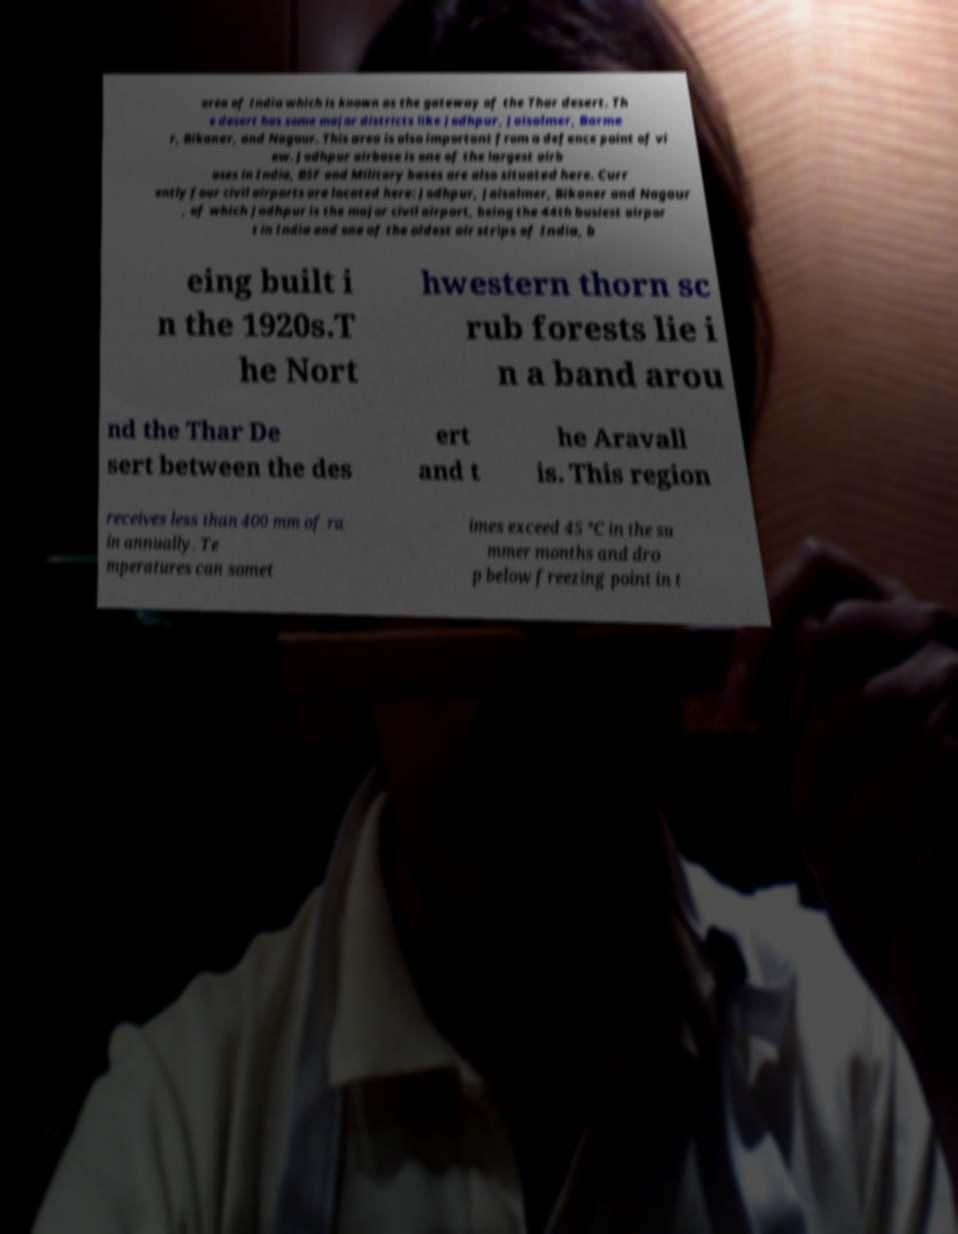Could you assist in decoding the text presented in this image and type it out clearly? area of India which is known as the gateway of the Thar desert. Th e desert has some major districts like Jodhpur, Jaisalmer, Barme r, Bikaner, and Nagour. This area is also important from a defence point of vi ew. Jodhpur airbase is one of the largest airb ases in India, BSF and Military bases are also situated here. Curr ently four civil airports are located here: Jodhpur, Jaisalmer, Bikaner and Nagaur , of which Jodhpur is the major civil airport, being the 44th busiest airpor t in India and one of the oldest air strips of India, b eing built i n the 1920s.T he Nort hwestern thorn sc rub forests lie i n a band arou nd the Thar De sert between the des ert and t he Aravall is. This region receives less than 400 mm of ra in annually. Te mperatures can somet imes exceed 45 °C in the su mmer months and dro p below freezing point in t 